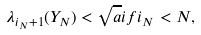Convert formula to latex. <formula><loc_0><loc_0><loc_500><loc_500>\lambda _ { i _ { N } + 1 } ( Y _ { N } ) < \sqrt { a } i f i _ { N } < N ,</formula> 